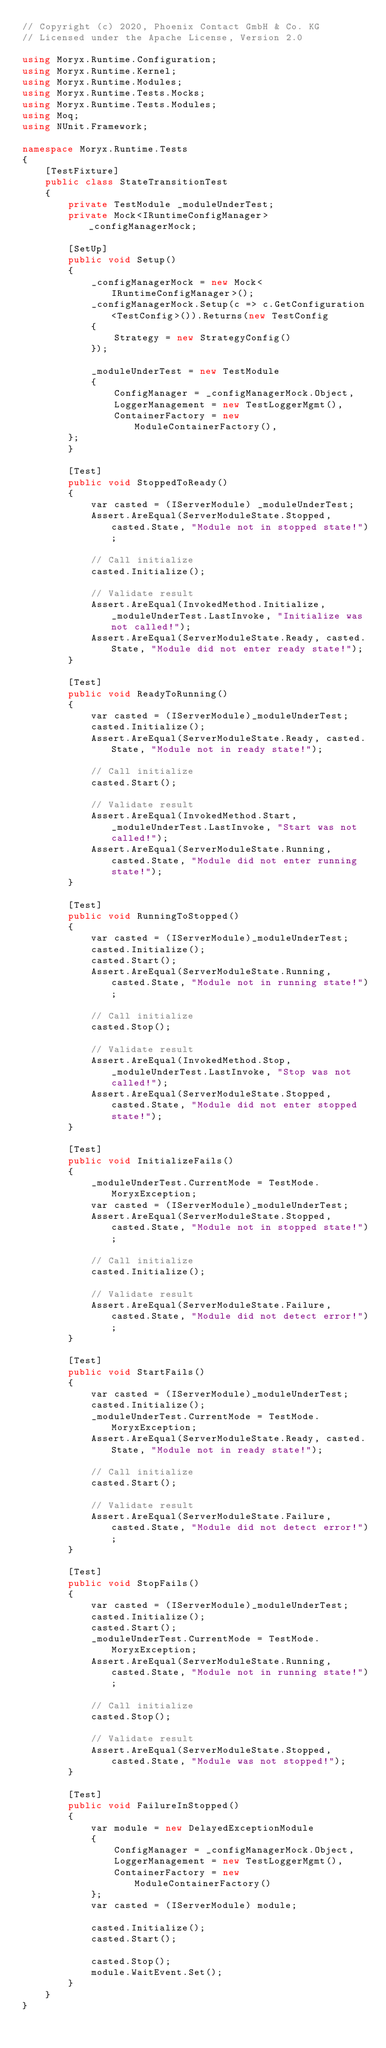<code> <loc_0><loc_0><loc_500><loc_500><_C#_>// Copyright (c) 2020, Phoenix Contact GmbH & Co. KG
// Licensed under the Apache License, Version 2.0

using Moryx.Runtime.Configuration;
using Moryx.Runtime.Kernel;
using Moryx.Runtime.Modules;
using Moryx.Runtime.Tests.Mocks;
using Moryx.Runtime.Tests.Modules;
using Moq;
using NUnit.Framework;

namespace Moryx.Runtime.Tests
{
    [TestFixture]
    public class StateTransitionTest
    {
        private TestModule _moduleUnderTest;
        private Mock<IRuntimeConfigManager> _configManagerMock;

        [SetUp]
        public void Setup()
        {
            _configManagerMock = new Mock<IRuntimeConfigManager>();
            _configManagerMock.Setup(c => c.GetConfiguration<TestConfig>()).Returns(new TestConfig
            {
                Strategy = new StrategyConfig()
            });

            _moduleUnderTest = new TestModule
            {
                ConfigManager = _configManagerMock.Object,
                LoggerManagement = new TestLoggerMgmt(),
                ContainerFactory = new ModuleContainerFactory(),
        };
        }

        [Test]
        public void StoppedToReady()
        {
            var casted = (IServerModule) _moduleUnderTest;
            Assert.AreEqual(ServerModuleState.Stopped, casted.State, "Module not in stopped state!");

            // Call initialize
            casted.Initialize();

            // Validate result
            Assert.AreEqual(InvokedMethod.Initialize, _moduleUnderTest.LastInvoke, "Initialize was not called!");
            Assert.AreEqual(ServerModuleState.Ready, casted.State, "Module did not enter ready state!");
        }

        [Test]
        public void ReadyToRunning()
        {
            var casted = (IServerModule)_moduleUnderTest;
            casted.Initialize();
            Assert.AreEqual(ServerModuleState.Ready, casted.State, "Module not in ready state!");

            // Call initialize
            casted.Start();

            // Validate result
            Assert.AreEqual(InvokedMethod.Start, _moduleUnderTest.LastInvoke, "Start was not called!");
            Assert.AreEqual(ServerModuleState.Running, casted.State, "Module did not enter running state!");
        }

        [Test]
        public void RunningToStopped()
        {
            var casted = (IServerModule)_moduleUnderTest;
            casted.Initialize();
            casted.Start();
            Assert.AreEqual(ServerModuleState.Running, casted.State, "Module not in running state!");

            // Call initialize
            casted.Stop();

            // Validate result
            Assert.AreEqual(InvokedMethod.Stop, _moduleUnderTest.LastInvoke, "Stop was not called!");
            Assert.AreEqual(ServerModuleState.Stopped, casted.State, "Module did not enter stopped state!");
        }

        [Test]
        public void InitializeFails()
        {
            _moduleUnderTest.CurrentMode = TestMode.MoryxException;
            var casted = (IServerModule)_moduleUnderTest;
            Assert.AreEqual(ServerModuleState.Stopped, casted.State, "Module not in stopped state!");

            // Call initialize
            casted.Initialize();

            // Validate result
            Assert.AreEqual(ServerModuleState.Failure, casted.State, "Module did not detect error!");
        }

        [Test]
        public void StartFails()
        {
            var casted = (IServerModule)_moduleUnderTest;
            casted.Initialize();
            _moduleUnderTest.CurrentMode = TestMode.MoryxException;
            Assert.AreEqual(ServerModuleState.Ready, casted.State, "Module not in ready state!");

            // Call initialize
            casted.Start();

            // Validate result
            Assert.AreEqual(ServerModuleState.Failure, casted.State, "Module did not detect error!");
        }

        [Test]
        public void StopFails()
        {
            var casted = (IServerModule)_moduleUnderTest;
            casted.Initialize();
            casted.Start();
            _moduleUnderTest.CurrentMode = TestMode.MoryxException;
            Assert.AreEqual(ServerModuleState.Running, casted.State, "Module not in running state!");

            // Call initialize
            casted.Stop();

            // Validate result
            Assert.AreEqual(ServerModuleState.Stopped, casted.State, "Module was not stopped!");
        }

        [Test]
        public void FailureInStopped()
        {
            var module = new DelayedExceptionModule
            {
                ConfigManager = _configManagerMock.Object,
                LoggerManagement = new TestLoggerMgmt(),
                ContainerFactory = new ModuleContainerFactory()
            };
            var casted = (IServerModule) module;

            casted.Initialize();
            casted.Start();

            casted.Stop();
            module.WaitEvent.Set();
        }
    }
}
</code> 